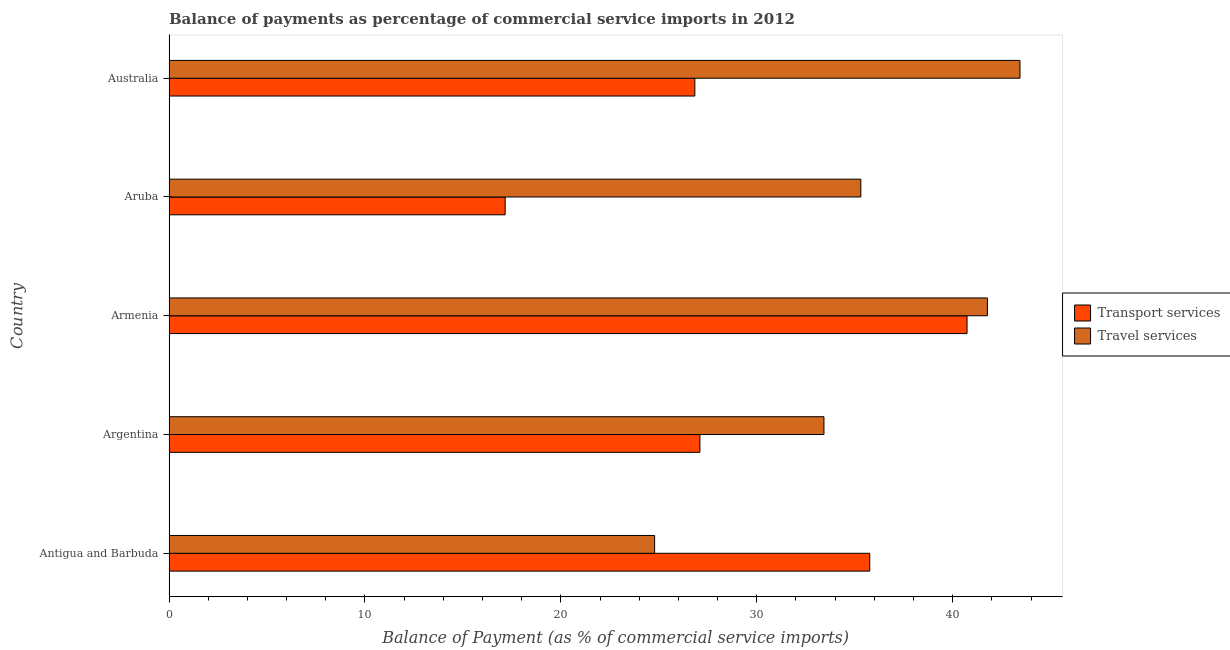How many groups of bars are there?
Your response must be concise. 5. What is the label of the 3rd group of bars from the top?
Provide a succinct answer. Armenia. What is the balance of payments of travel services in Antigua and Barbuda?
Offer a terse response. 24.79. Across all countries, what is the maximum balance of payments of transport services?
Provide a short and direct response. 40.73. Across all countries, what is the minimum balance of payments of travel services?
Make the answer very short. 24.79. In which country was the balance of payments of travel services maximum?
Make the answer very short. Australia. In which country was the balance of payments of transport services minimum?
Offer a terse response. Aruba. What is the total balance of payments of travel services in the graph?
Give a very brief answer. 178.74. What is the difference between the balance of payments of travel services in Argentina and that in Armenia?
Offer a terse response. -8.34. What is the difference between the balance of payments of travel services in Argentina and the balance of payments of transport services in Antigua and Barbuda?
Provide a succinct answer. -2.34. What is the average balance of payments of transport services per country?
Ensure brevity in your answer.  29.52. What is the difference between the balance of payments of transport services and balance of payments of travel services in Argentina?
Your response must be concise. -6.33. What is the ratio of the balance of payments of transport services in Antigua and Barbuda to that in Aruba?
Offer a very short reply. 2.08. What is the difference between the highest and the second highest balance of payments of transport services?
Your answer should be very brief. 4.97. What is the difference between the highest and the lowest balance of payments of transport services?
Offer a very short reply. 23.58. Is the sum of the balance of payments of transport services in Argentina and Armenia greater than the maximum balance of payments of travel services across all countries?
Make the answer very short. Yes. What does the 2nd bar from the top in Antigua and Barbuda represents?
Offer a terse response. Transport services. What does the 2nd bar from the bottom in Australia represents?
Keep it short and to the point. Travel services. How many bars are there?
Offer a terse response. 10. Are all the bars in the graph horizontal?
Your answer should be very brief. Yes. How many countries are there in the graph?
Offer a very short reply. 5. Does the graph contain grids?
Your answer should be very brief. No. Where does the legend appear in the graph?
Ensure brevity in your answer.  Center right. How many legend labels are there?
Your answer should be compact. 2. What is the title of the graph?
Ensure brevity in your answer.  Balance of payments as percentage of commercial service imports in 2012. What is the label or title of the X-axis?
Keep it short and to the point. Balance of Payment (as % of commercial service imports). What is the Balance of Payment (as % of commercial service imports) of Transport services in Antigua and Barbuda?
Offer a terse response. 35.77. What is the Balance of Payment (as % of commercial service imports) of Travel services in Antigua and Barbuda?
Offer a terse response. 24.79. What is the Balance of Payment (as % of commercial service imports) of Transport services in Argentina?
Give a very brief answer. 27.1. What is the Balance of Payment (as % of commercial service imports) in Travel services in Argentina?
Make the answer very short. 33.43. What is the Balance of Payment (as % of commercial service imports) of Transport services in Armenia?
Give a very brief answer. 40.73. What is the Balance of Payment (as % of commercial service imports) in Travel services in Armenia?
Offer a very short reply. 41.77. What is the Balance of Payment (as % of commercial service imports) in Transport services in Aruba?
Ensure brevity in your answer.  17.16. What is the Balance of Payment (as % of commercial service imports) of Travel services in Aruba?
Provide a succinct answer. 35.31. What is the Balance of Payment (as % of commercial service imports) in Transport services in Australia?
Your answer should be very brief. 26.84. What is the Balance of Payment (as % of commercial service imports) in Travel services in Australia?
Ensure brevity in your answer.  43.44. Across all countries, what is the maximum Balance of Payment (as % of commercial service imports) of Transport services?
Your answer should be very brief. 40.73. Across all countries, what is the maximum Balance of Payment (as % of commercial service imports) of Travel services?
Your response must be concise. 43.44. Across all countries, what is the minimum Balance of Payment (as % of commercial service imports) of Transport services?
Offer a very short reply. 17.16. Across all countries, what is the minimum Balance of Payment (as % of commercial service imports) of Travel services?
Offer a terse response. 24.79. What is the total Balance of Payment (as % of commercial service imports) of Transport services in the graph?
Offer a terse response. 147.6. What is the total Balance of Payment (as % of commercial service imports) of Travel services in the graph?
Your answer should be very brief. 178.74. What is the difference between the Balance of Payment (as % of commercial service imports) in Transport services in Antigua and Barbuda and that in Argentina?
Give a very brief answer. 8.67. What is the difference between the Balance of Payment (as % of commercial service imports) in Travel services in Antigua and Barbuda and that in Argentina?
Keep it short and to the point. -8.64. What is the difference between the Balance of Payment (as % of commercial service imports) of Transport services in Antigua and Barbuda and that in Armenia?
Your answer should be very brief. -4.97. What is the difference between the Balance of Payment (as % of commercial service imports) of Travel services in Antigua and Barbuda and that in Armenia?
Your answer should be very brief. -16.99. What is the difference between the Balance of Payment (as % of commercial service imports) in Transport services in Antigua and Barbuda and that in Aruba?
Give a very brief answer. 18.61. What is the difference between the Balance of Payment (as % of commercial service imports) of Travel services in Antigua and Barbuda and that in Aruba?
Your response must be concise. -10.53. What is the difference between the Balance of Payment (as % of commercial service imports) in Transport services in Antigua and Barbuda and that in Australia?
Your response must be concise. 8.93. What is the difference between the Balance of Payment (as % of commercial service imports) of Travel services in Antigua and Barbuda and that in Australia?
Your response must be concise. -18.65. What is the difference between the Balance of Payment (as % of commercial service imports) in Transport services in Argentina and that in Armenia?
Provide a short and direct response. -13.64. What is the difference between the Balance of Payment (as % of commercial service imports) of Travel services in Argentina and that in Armenia?
Offer a very short reply. -8.34. What is the difference between the Balance of Payment (as % of commercial service imports) in Transport services in Argentina and that in Aruba?
Your answer should be compact. 9.94. What is the difference between the Balance of Payment (as % of commercial service imports) of Travel services in Argentina and that in Aruba?
Give a very brief answer. -1.88. What is the difference between the Balance of Payment (as % of commercial service imports) of Transport services in Argentina and that in Australia?
Your answer should be very brief. 0.26. What is the difference between the Balance of Payment (as % of commercial service imports) of Travel services in Argentina and that in Australia?
Keep it short and to the point. -10.01. What is the difference between the Balance of Payment (as % of commercial service imports) of Transport services in Armenia and that in Aruba?
Your answer should be compact. 23.58. What is the difference between the Balance of Payment (as % of commercial service imports) in Travel services in Armenia and that in Aruba?
Provide a short and direct response. 6.46. What is the difference between the Balance of Payment (as % of commercial service imports) in Transport services in Armenia and that in Australia?
Ensure brevity in your answer.  13.89. What is the difference between the Balance of Payment (as % of commercial service imports) in Travel services in Armenia and that in Australia?
Provide a succinct answer. -1.66. What is the difference between the Balance of Payment (as % of commercial service imports) of Transport services in Aruba and that in Australia?
Your response must be concise. -9.68. What is the difference between the Balance of Payment (as % of commercial service imports) in Travel services in Aruba and that in Australia?
Your answer should be compact. -8.12. What is the difference between the Balance of Payment (as % of commercial service imports) in Transport services in Antigua and Barbuda and the Balance of Payment (as % of commercial service imports) in Travel services in Argentina?
Your answer should be very brief. 2.34. What is the difference between the Balance of Payment (as % of commercial service imports) in Transport services in Antigua and Barbuda and the Balance of Payment (as % of commercial service imports) in Travel services in Armenia?
Offer a terse response. -6.01. What is the difference between the Balance of Payment (as % of commercial service imports) in Transport services in Antigua and Barbuda and the Balance of Payment (as % of commercial service imports) in Travel services in Aruba?
Provide a succinct answer. 0.46. What is the difference between the Balance of Payment (as % of commercial service imports) of Transport services in Antigua and Barbuda and the Balance of Payment (as % of commercial service imports) of Travel services in Australia?
Offer a very short reply. -7.67. What is the difference between the Balance of Payment (as % of commercial service imports) in Transport services in Argentina and the Balance of Payment (as % of commercial service imports) in Travel services in Armenia?
Your response must be concise. -14.68. What is the difference between the Balance of Payment (as % of commercial service imports) of Transport services in Argentina and the Balance of Payment (as % of commercial service imports) of Travel services in Aruba?
Make the answer very short. -8.21. What is the difference between the Balance of Payment (as % of commercial service imports) in Transport services in Argentina and the Balance of Payment (as % of commercial service imports) in Travel services in Australia?
Make the answer very short. -16.34. What is the difference between the Balance of Payment (as % of commercial service imports) in Transport services in Armenia and the Balance of Payment (as % of commercial service imports) in Travel services in Aruba?
Your answer should be compact. 5.42. What is the difference between the Balance of Payment (as % of commercial service imports) of Transport services in Armenia and the Balance of Payment (as % of commercial service imports) of Travel services in Australia?
Make the answer very short. -2.7. What is the difference between the Balance of Payment (as % of commercial service imports) of Transport services in Aruba and the Balance of Payment (as % of commercial service imports) of Travel services in Australia?
Your answer should be very brief. -26.28. What is the average Balance of Payment (as % of commercial service imports) of Transport services per country?
Keep it short and to the point. 29.52. What is the average Balance of Payment (as % of commercial service imports) in Travel services per country?
Offer a terse response. 35.75. What is the difference between the Balance of Payment (as % of commercial service imports) in Transport services and Balance of Payment (as % of commercial service imports) in Travel services in Antigua and Barbuda?
Your response must be concise. 10.98. What is the difference between the Balance of Payment (as % of commercial service imports) of Transport services and Balance of Payment (as % of commercial service imports) of Travel services in Argentina?
Keep it short and to the point. -6.33. What is the difference between the Balance of Payment (as % of commercial service imports) in Transport services and Balance of Payment (as % of commercial service imports) in Travel services in Armenia?
Your answer should be compact. -1.04. What is the difference between the Balance of Payment (as % of commercial service imports) in Transport services and Balance of Payment (as % of commercial service imports) in Travel services in Aruba?
Provide a short and direct response. -18.15. What is the difference between the Balance of Payment (as % of commercial service imports) of Transport services and Balance of Payment (as % of commercial service imports) of Travel services in Australia?
Your response must be concise. -16.6. What is the ratio of the Balance of Payment (as % of commercial service imports) of Transport services in Antigua and Barbuda to that in Argentina?
Your answer should be compact. 1.32. What is the ratio of the Balance of Payment (as % of commercial service imports) of Travel services in Antigua and Barbuda to that in Argentina?
Your response must be concise. 0.74. What is the ratio of the Balance of Payment (as % of commercial service imports) in Transport services in Antigua and Barbuda to that in Armenia?
Your answer should be compact. 0.88. What is the ratio of the Balance of Payment (as % of commercial service imports) in Travel services in Antigua and Barbuda to that in Armenia?
Offer a terse response. 0.59. What is the ratio of the Balance of Payment (as % of commercial service imports) of Transport services in Antigua and Barbuda to that in Aruba?
Provide a short and direct response. 2.08. What is the ratio of the Balance of Payment (as % of commercial service imports) in Travel services in Antigua and Barbuda to that in Aruba?
Ensure brevity in your answer.  0.7. What is the ratio of the Balance of Payment (as % of commercial service imports) of Transport services in Antigua and Barbuda to that in Australia?
Offer a terse response. 1.33. What is the ratio of the Balance of Payment (as % of commercial service imports) in Travel services in Antigua and Barbuda to that in Australia?
Ensure brevity in your answer.  0.57. What is the ratio of the Balance of Payment (as % of commercial service imports) in Transport services in Argentina to that in Armenia?
Keep it short and to the point. 0.67. What is the ratio of the Balance of Payment (as % of commercial service imports) in Travel services in Argentina to that in Armenia?
Your response must be concise. 0.8. What is the ratio of the Balance of Payment (as % of commercial service imports) of Transport services in Argentina to that in Aruba?
Your answer should be compact. 1.58. What is the ratio of the Balance of Payment (as % of commercial service imports) of Travel services in Argentina to that in Aruba?
Your answer should be very brief. 0.95. What is the ratio of the Balance of Payment (as % of commercial service imports) of Transport services in Argentina to that in Australia?
Give a very brief answer. 1.01. What is the ratio of the Balance of Payment (as % of commercial service imports) of Travel services in Argentina to that in Australia?
Ensure brevity in your answer.  0.77. What is the ratio of the Balance of Payment (as % of commercial service imports) in Transport services in Armenia to that in Aruba?
Keep it short and to the point. 2.37. What is the ratio of the Balance of Payment (as % of commercial service imports) in Travel services in Armenia to that in Aruba?
Provide a short and direct response. 1.18. What is the ratio of the Balance of Payment (as % of commercial service imports) of Transport services in Armenia to that in Australia?
Your response must be concise. 1.52. What is the ratio of the Balance of Payment (as % of commercial service imports) in Travel services in Armenia to that in Australia?
Make the answer very short. 0.96. What is the ratio of the Balance of Payment (as % of commercial service imports) in Transport services in Aruba to that in Australia?
Give a very brief answer. 0.64. What is the ratio of the Balance of Payment (as % of commercial service imports) of Travel services in Aruba to that in Australia?
Your response must be concise. 0.81. What is the difference between the highest and the second highest Balance of Payment (as % of commercial service imports) in Transport services?
Offer a terse response. 4.97. What is the difference between the highest and the second highest Balance of Payment (as % of commercial service imports) in Travel services?
Offer a very short reply. 1.66. What is the difference between the highest and the lowest Balance of Payment (as % of commercial service imports) in Transport services?
Keep it short and to the point. 23.58. What is the difference between the highest and the lowest Balance of Payment (as % of commercial service imports) in Travel services?
Your answer should be compact. 18.65. 